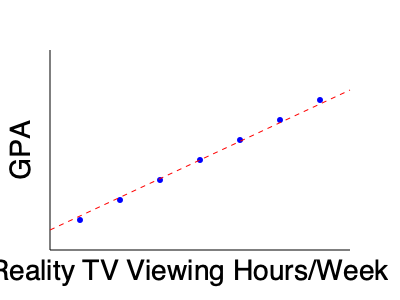Based on the scatter plot showing the relationship between reality TV viewing hours per week and GPA, what can be inferred about the correlation between these two variables? To analyze the correlation between reality TV viewing hours and GPA, we need to examine the scatter plot:

1. Observe the overall trend: As we move from left to right (increasing TV viewing hours), the points tend to move downward (decreasing GPA).

2. Direction of correlation: This downward trend indicates a negative correlation between TV viewing hours and GPA.

3. Strength of correlation: The points form a fairly straight line with minimal scatter, suggesting a strong correlation.

4. Line of best fit: The red dashed line represents the line of best fit, which clearly shows a downward slope, confirming the negative correlation.

5. Interpretation: As reality TV viewing hours increase, GPA tends to decrease, suggesting that more time spent watching reality TV is associated with lower academic performance.

6. Caution: While there is a correlation, we cannot conclude causation. Other factors may influence both TV viewing habits and academic performance.

This data supports the skeptical sibling's view that reality TV might be taking time away from more academically beneficial activities, potentially impacting school performance.
Answer: Strong negative correlation between reality TV viewing hours and GPA 